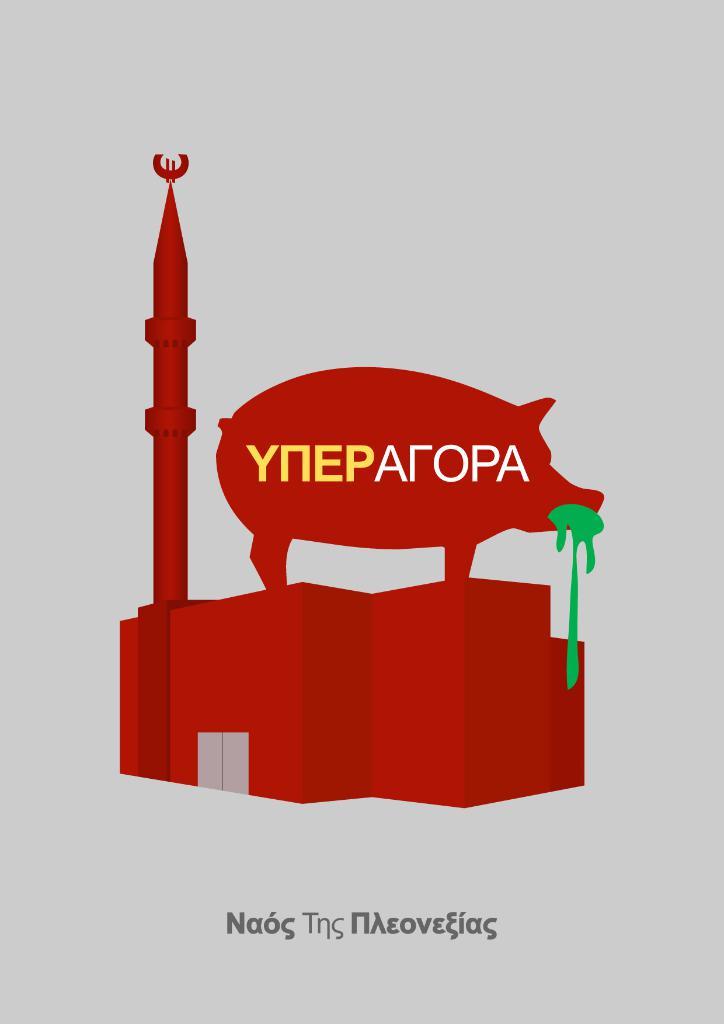What is wrote in yellow and white?
Your response must be concise. Yneparopa. 